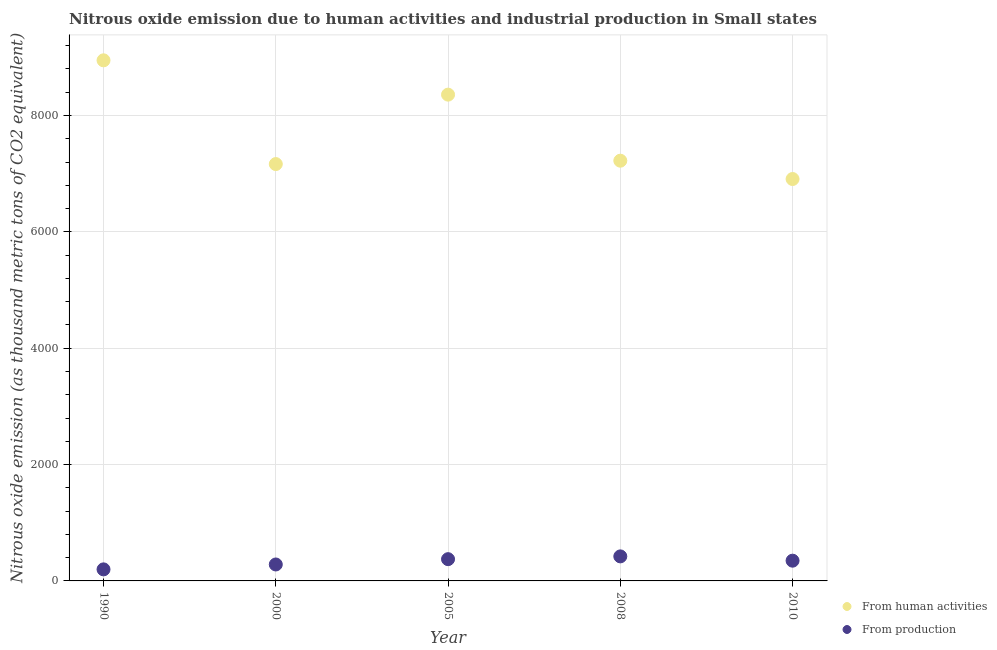Is the number of dotlines equal to the number of legend labels?
Provide a succinct answer. Yes. What is the amount of emissions generated from industries in 2008?
Offer a terse response. 421.7. Across all years, what is the maximum amount of emissions generated from industries?
Offer a very short reply. 421.7. Across all years, what is the minimum amount of emissions from human activities?
Make the answer very short. 6907.8. In which year was the amount of emissions generated from industries maximum?
Provide a short and direct response. 2008. What is the total amount of emissions generated from industries in the graph?
Your answer should be very brief. 1624.7. What is the difference between the amount of emissions from human activities in 1990 and that in 2005?
Ensure brevity in your answer.  589.7. What is the difference between the amount of emissions from human activities in 1990 and the amount of emissions generated from industries in 2008?
Offer a terse response. 8526.1. What is the average amount of emissions generated from industries per year?
Give a very brief answer. 324.94. In the year 2008, what is the difference between the amount of emissions generated from industries and amount of emissions from human activities?
Provide a short and direct response. -6801. In how many years, is the amount of emissions from human activities greater than 2400 thousand metric tons?
Provide a short and direct response. 5. What is the ratio of the amount of emissions generated from industries in 1990 to that in 2008?
Give a very brief answer. 0.47. Is the amount of emissions from human activities in 2005 less than that in 2010?
Keep it short and to the point. No. Is the difference between the amount of emissions generated from industries in 2000 and 2005 greater than the difference between the amount of emissions from human activities in 2000 and 2005?
Give a very brief answer. Yes. What is the difference between the highest and the second highest amount of emissions from human activities?
Your answer should be compact. 589.7. What is the difference between the highest and the lowest amount of emissions from human activities?
Offer a very short reply. 2040. In how many years, is the amount of emissions from human activities greater than the average amount of emissions from human activities taken over all years?
Give a very brief answer. 2. Is the sum of the amount of emissions generated from industries in 1990 and 2008 greater than the maximum amount of emissions from human activities across all years?
Give a very brief answer. No. Does the amount of emissions from human activities monotonically increase over the years?
Your answer should be very brief. No. Is the amount of emissions generated from industries strictly greater than the amount of emissions from human activities over the years?
Keep it short and to the point. No. Does the graph contain grids?
Provide a short and direct response. Yes. Where does the legend appear in the graph?
Your answer should be compact. Bottom right. How are the legend labels stacked?
Provide a succinct answer. Vertical. What is the title of the graph?
Offer a very short reply. Nitrous oxide emission due to human activities and industrial production in Small states. What is the label or title of the X-axis?
Your answer should be very brief. Year. What is the label or title of the Y-axis?
Provide a succinct answer. Nitrous oxide emission (as thousand metric tons of CO2 equivalent). What is the Nitrous oxide emission (as thousand metric tons of CO2 equivalent) in From human activities in 1990?
Your answer should be compact. 8947.8. What is the Nitrous oxide emission (as thousand metric tons of CO2 equivalent) of From production in 1990?
Give a very brief answer. 198.5. What is the Nitrous oxide emission (as thousand metric tons of CO2 equivalent) of From human activities in 2000?
Your answer should be compact. 7164.7. What is the Nitrous oxide emission (as thousand metric tons of CO2 equivalent) in From production in 2000?
Your response must be concise. 282.6. What is the Nitrous oxide emission (as thousand metric tons of CO2 equivalent) in From human activities in 2005?
Provide a short and direct response. 8358.1. What is the Nitrous oxide emission (as thousand metric tons of CO2 equivalent) of From production in 2005?
Make the answer very short. 374. What is the Nitrous oxide emission (as thousand metric tons of CO2 equivalent) of From human activities in 2008?
Offer a terse response. 7222.7. What is the Nitrous oxide emission (as thousand metric tons of CO2 equivalent) in From production in 2008?
Provide a succinct answer. 421.7. What is the Nitrous oxide emission (as thousand metric tons of CO2 equivalent) in From human activities in 2010?
Your answer should be compact. 6907.8. What is the Nitrous oxide emission (as thousand metric tons of CO2 equivalent) of From production in 2010?
Your answer should be very brief. 347.9. Across all years, what is the maximum Nitrous oxide emission (as thousand metric tons of CO2 equivalent) of From human activities?
Provide a short and direct response. 8947.8. Across all years, what is the maximum Nitrous oxide emission (as thousand metric tons of CO2 equivalent) in From production?
Offer a very short reply. 421.7. Across all years, what is the minimum Nitrous oxide emission (as thousand metric tons of CO2 equivalent) in From human activities?
Your response must be concise. 6907.8. Across all years, what is the minimum Nitrous oxide emission (as thousand metric tons of CO2 equivalent) in From production?
Offer a very short reply. 198.5. What is the total Nitrous oxide emission (as thousand metric tons of CO2 equivalent) of From human activities in the graph?
Your response must be concise. 3.86e+04. What is the total Nitrous oxide emission (as thousand metric tons of CO2 equivalent) in From production in the graph?
Your answer should be compact. 1624.7. What is the difference between the Nitrous oxide emission (as thousand metric tons of CO2 equivalent) in From human activities in 1990 and that in 2000?
Give a very brief answer. 1783.1. What is the difference between the Nitrous oxide emission (as thousand metric tons of CO2 equivalent) of From production in 1990 and that in 2000?
Your answer should be compact. -84.1. What is the difference between the Nitrous oxide emission (as thousand metric tons of CO2 equivalent) of From human activities in 1990 and that in 2005?
Give a very brief answer. 589.7. What is the difference between the Nitrous oxide emission (as thousand metric tons of CO2 equivalent) of From production in 1990 and that in 2005?
Give a very brief answer. -175.5. What is the difference between the Nitrous oxide emission (as thousand metric tons of CO2 equivalent) of From human activities in 1990 and that in 2008?
Offer a terse response. 1725.1. What is the difference between the Nitrous oxide emission (as thousand metric tons of CO2 equivalent) of From production in 1990 and that in 2008?
Your answer should be very brief. -223.2. What is the difference between the Nitrous oxide emission (as thousand metric tons of CO2 equivalent) of From human activities in 1990 and that in 2010?
Offer a terse response. 2040. What is the difference between the Nitrous oxide emission (as thousand metric tons of CO2 equivalent) of From production in 1990 and that in 2010?
Your answer should be very brief. -149.4. What is the difference between the Nitrous oxide emission (as thousand metric tons of CO2 equivalent) in From human activities in 2000 and that in 2005?
Offer a terse response. -1193.4. What is the difference between the Nitrous oxide emission (as thousand metric tons of CO2 equivalent) of From production in 2000 and that in 2005?
Keep it short and to the point. -91.4. What is the difference between the Nitrous oxide emission (as thousand metric tons of CO2 equivalent) of From human activities in 2000 and that in 2008?
Offer a terse response. -58. What is the difference between the Nitrous oxide emission (as thousand metric tons of CO2 equivalent) of From production in 2000 and that in 2008?
Your answer should be very brief. -139.1. What is the difference between the Nitrous oxide emission (as thousand metric tons of CO2 equivalent) of From human activities in 2000 and that in 2010?
Ensure brevity in your answer.  256.9. What is the difference between the Nitrous oxide emission (as thousand metric tons of CO2 equivalent) in From production in 2000 and that in 2010?
Your answer should be very brief. -65.3. What is the difference between the Nitrous oxide emission (as thousand metric tons of CO2 equivalent) in From human activities in 2005 and that in 2008?
Your answer should be compact. 1135.4. What is the difference between the Nitrous oxide emission (as thousand metric tons of CO2 equivalent) of From production in 2005 and that in 2008?
Offer a very short reply. -47.7. What is the difference between the Nitrous oxide emission (as thousand metric tons of CO2 equivalent) of From human activities in 2005 and that in 2010?
Offer a very short reply. 1450.3. What is the difference between the Nitrous oxide emission (as thousand metric tons of CO2 equivalent) in From production in 2005 and that in 2010?
Offer a terse response. 26.1. What is the difference between the Nitrous oxide emission (as thousand metric tons of CO2 equivalent) of From human activities in 2008 and that in 2010?
Make the answer very short. 314.9. What is the difference between the Nitrous oxide emission (as thousand metric tons of CO2 equivalent) in From production in 2008 and that in 2010?
Your answer should be compact. 73.8. What is the difference between the Nitrous oxide emission (as thousand metric tons of CO2 equivalent) of From human activities in 1990 and the Nitrous oxide emission (as thousand metric tons of CO2 equivalent) of From production in 2000?
Your answer should be compact. 8665.2. What is the difference between the Nitrous oxide emission (as thousand metric tons of CO2 equivalent) of From human activities in 1990 and the Nitrous oxide emission (as thousand metric tons of CO2 equivalent) of From production in 2005?
Offer a very short reply. 8573.8. What is the difference between the Nitrous oxide emission (as thousand metric tons of CO2 equivalent) of From human activities in 1990 and the Nitrous oxide emission (as thousand metric tons of CO2 equivalent) of From production in 2008?
Your answer should be very brief. 8526.1. What is the difference between the Nitrous oxide emission (as thousand metric tons of CO2 equivalent) in From human activities in 1990 and the Nitrous oxide emission (as thousand metric tons of CO2 equivalent) in From production in 2010?
Keep it short and to the point. 8599.9. What is the difference between the Nitrous oxide emission (as thousand metric tons of CO2 equivalent) in From human activities in 2000 and the Nitrous oxide emission (as thousand metric tons of CO2 equivalent) in From production in 2005?
Offer a very short reply. 6790.7. What is the difference between the Nitrous oxide emission (as thousand metric tons of CO2 equivalent) of From human activities in 2000 and the Nitrous oxide emission (as thousand metric tons of CO2 equivalent) of From production in 2008?
Provide a short and direct response. 6743. What is the difference between the Nitrous oxide emission (as thousand metric tons of CO2 equivalent) of From human activities in 2000 and the Nitrous oxide emission (as thousand metric tons of CO2 equivalent) of From production in 2010?
Keep it short and to the point. 6816.8. What is the difference between the Nitrous oxide emission (as thousand metric tons of CO2 equivalent) in From human activities in 2005 and the Nitrous oxide emission (as thousand metric tons of CO2 equivalent) in From production in 2008?
Offer a terse response. 7936.4. What is the difference between the Nitrous oxide emission (as thousand metric tons of CO2 equivalent) of From human activities in 2005 and the Nitrous oxide emission (as thousand metric tons of CO2 equivalent) of From production in 2010?
Your response must be concise. 8010.2. What is the difference between the Nitrous oxide emission (as thousand metric tons of CO2 equivalent) in From human activities in 2008 and the Nitrous oxide emission (as thousand metric tons of CO2 equivalent) in From production in 2010?
Your response must be concise. 6874.8. What is the average Nitrous oxide emission (as thousand metric tons of CO2 equivalent) of From human activities per year?
Provide a succinct answer. 7720.22. What is the average Nitrous oxide emission (as thousand metric tons of CO2 equivalent) in From production per year?
Keep it short and to the point. 324.94. In the year 1990, what is the difference between the Nitrous oxide emission (as thousand metric tons of CO2 equivalent) of From human activities and Nitrous oxide emission (as thousand metric tons of CO2 equivalent) of From production?
Your response must be concise. 8749.3. In the year 2000, what is the difference between the Nitrous oxide emission (as thousand metric tons of CO2 equivalent) in From human activities and Nitrous oxide emission (as thousand metric tons of CO2 equivalent) in From production?
Your response must be concise. 6882.1. In the year 2005, what is the difference between the Nitrous oxide emission (as thousand metric tons of CO2 equivalent) in From human activities and Nitrous oxide emission (as thousand metric tons of CO2 equivalent) in From production?
Give a very brief answer. 7984.1. In the year 2008, what is the difference between the Nitrous oxide emission (as thousand metric tons of CO2 equivalent) in From human activities and Nitrous oxide emission (as thousand metric tons of CO2 equivalent) in From production?
Keep it short and to the point. 6801. In the year 2010, what is the difference between the Nitrous oxide emission (as thousand metric tons of CO2 equivalent) of From human activities and Nitrous oxide emission (as thousand metric tons of CO2 equivalent) of From production?
Your answer should be compact. 6559.9. What is the ratio of the Nitrous oxide emission (as thousand metric tons of CO2 equivalent) in From human activities in 1990 to that in 2000?
Offer a terse response. 1.25. What is the ratio of the Nitrous oxide emission (as thousand metric tons of CO2 equivalent) in From production in 1990 to that in 2000?
Your answer should be compact. 0.7. What is the ratio of the Nitrous oxide emission (as thousand metric tons of CO2 equivalent) in From human activities in 1990 to that in 2005?
Your response must be concise. 1.07. What is the ratio of the Nitrous oxide emission (as thousand metric tons of CO2 equivalent) in From production in 1990 to that in 2005?
Your answer should be compact. 0.53. What is the ratio of the Nitrous oxide emission (as thousand metric tons of CO2 equivalent) of From human activities in 1990 to that in 2008?
Your answer should be compact. 1.24. What is the ratio of the Nitrous oxide emission (as thousand metric tons of CO2 equivalent) in From production in 1990 to that in 2008?
Give a very brief answer. 0.47. What is the ratio of the Nitrous oxide emission (as thousand metric tons of CO2 equivalent) in From human activities in 1990 to that in 2010?
Offer a very short reply. 1.3. What is the ratio of the Nitrous oxide emission (as thousand metric tons of CO2 equivalent) in From production in 1990 to that in 2010?
Your response must be concise. 0.57. What is the ratio of the Nitrous oxide emission (as thousand metric tons of CO2 equivalent) in From human activities in 2000 to that in 2005?
Offer a very short reply. 0.86. What is the ratio of the Nitrous oxide emission (as thousand metric tons of CO2 equivalent) of From production in 2000 to that in 2005?
Offer a terse response. 0.76. What is the ratio of the Nitrous oxide emission (as thousand metric tons of CO2 equivalent) of From production in 2000 to that in 2008?
Your answer should be compact. 0.67. What is the ratio of the Nitrous oxide emission (as thousand metric tons of CO2 equivalent) of From human activities in 2000 to that in 2010?
Give a very brief answer. 1.04. What is the ratio of the Nitrous oxide emission (as thousand metric tons of CO2 equivalent) of From production in 2000 to that in 2010?
Offer a very short reply. 0.81. What is the ratio of the Nitrous oxide emission (as thousand metric tons of CO2 equivalent) in From human activities in 2005 to that in 2008?
Provide a short and direct response. 1.16. What is the ratio of the Nitrous oxide emission (as thousand metric tons of CO2 equivalent) in From production in 2005 to that in 2008?
Offer a very short reply. 0.89. What is the ratio of the Nitrous oxide emission (as thousand metric tons of CO2 equivalent) of From human activities in 2005 to that in 2010?
Give a very brief answer. 1.21. What is the ratio of the Nitrous oxide emission (as thousand metric tons of CO2 equivalent) of From production in 2005 to that in 2010?
Keep it short and to the point. 1.07. What is the ratio of the Nitrous oxide emission (as thousand metric tons of CO2 equivalent) in From human activities in 2008 to that in 2010?
Give a very brief answer. 1.05. What is the ratio of the Nitrous oxide emission (as thousand metric tons of CO2 equivalent) of From production in 2008 to that in 2010?
Make the answer very short. 1.21. What is the difference between the highest and the second highest Nitrous oxide emission (as thousand metric tons of CO2 equivalent) of From human activities?
Keep it short and to the point. 589.7. What is the difference between the highest and the second highest Nitrous oxide emission (as thousand metric tons of CO2 equivalent) in From production?
Give a very brief answer. 47.7. What is the difference between the highest and the lowest Nitrous oxide emission (as thousand metric tons of CO2 equivalent) in From human activities?
Keep it short and to the point. 2040. What is the difference between the highest and the lowest Nitrous oxide emission (as thousand metric tons of CO2 equivalent) in From production?
Ensure brevity in your answer.  223.2. 